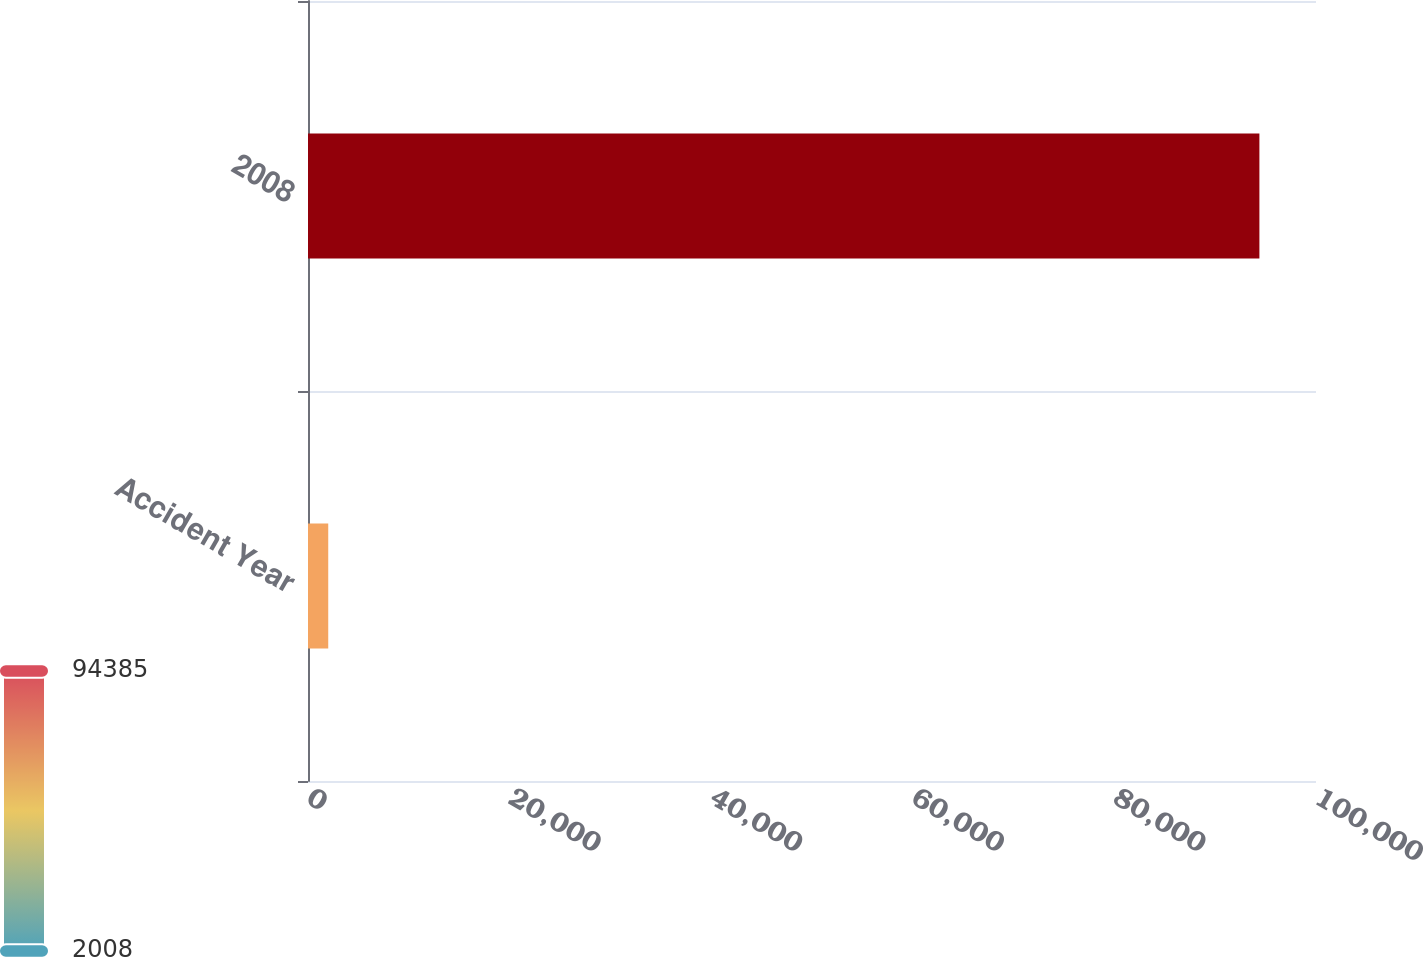Convert chart to OTSL. <chart><loc_0><loc_0><loc_500><loc_500><bar_chart><fcel>Accident Year<fcel>2008<nl><fcel>2008<fcel>94385<nl></chart> 